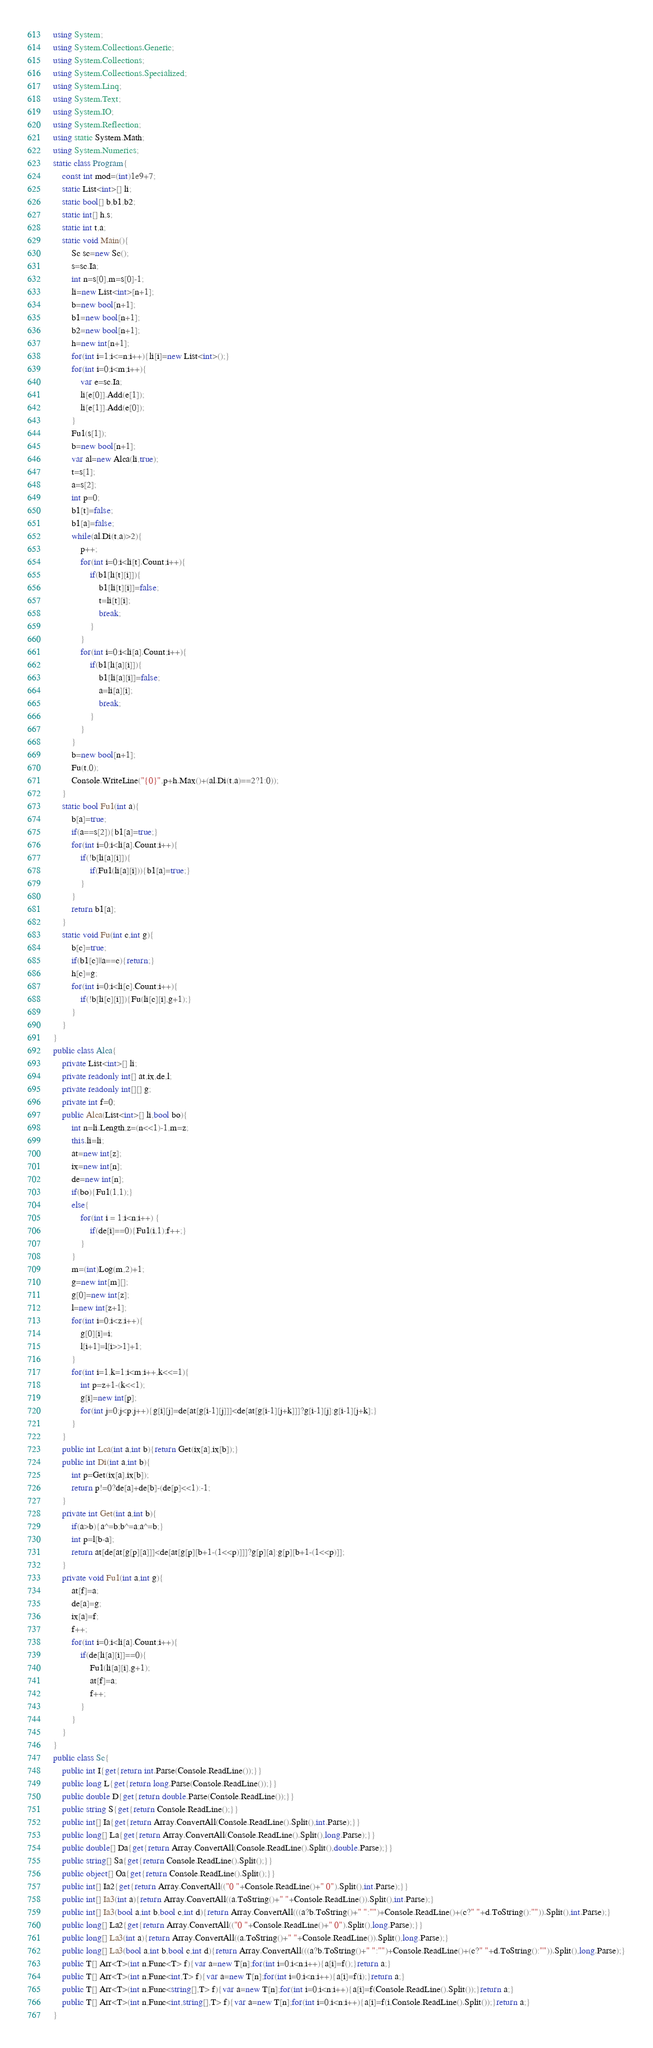Convert code to text. <code><loc_0><loc_0><loc_500><loc_500><_C#_>using System;
using System.Collections.Generic;
using System.Collections;
using System.Collections.Specialized;
using System.Linq;
using System.Text;
using System.IO;
using System.Reflection;
using static System.Math;
using System.Numerics;
static class Program{
	const int mod=(int)1e9+7;
	static List<int>[] li;
	static bool[] b,b1,b2;
	static int[] h,s;
	static int t,a;
	static void Main(){
		Sc sc=new Sc();
		s=sc.Ia;
		int n=s[0],m=s[0]-1;
		li=new List<int>[n+1];
		b=new bool[n+1];
		b1=new bool[n+1];
		b2=new bool[n+1];
		h=new int[n+1];
		for(int i=1;i<=n;i++){li[i]=new List<int>();}
		for(int i=0;i<m;i++){
			var e=sc.Ia;
			li[e[0]].Add(e[1]);
			li[e[1]].Add(e[0]);
		}
		Fu1(s[1]);
		b=new bool[n+1];
		var al=new Alca(li,true);
		t=s[1];
		a=s[2];
		int p=0;
		b1[t]=false;
		b1[a]=false;
		while(al.Di(t,a)>2){
			p++;
			for(int i=0;i<li[t].Count;i++){
				if(b1[li[t][i]]){
					b1[li[t][i]]=false;
					t=li[t][i];
					break;
				}
			}
			for(int i=0;i<li[a].Count;i++){
				if(b1[li[a][i]]){
					b1[li[a][i]]=false;
					a=li[a][i];
					break;
				}
			}
		}
		b=new bool[n+1];
		Fu(t,0);
		Console.WriteLine("{0}",p+h.Max()+(al.Di(t,a)==2?1:0));
	}
	static bool Fu1(int a){
		b[a]=true;
		if(a==s[2]){b1[a]=true;}
		for(int i=0;i<li[a].Count;i++){
			if(!b[li[a][i]]){
				if(Fu1(li[a][i])){b1[a]=true;}
			}
		}
		return b1[a];
	}
	static void Fu(int c,int g){
		b[c]=true;
		if(b1[c]||a==c){return;}
		h[c]=g;
		for(int i=0;i<li[c].Count;i++){
			if(!b[li[c][i]]){Fu(li[c][i],g+1);}
		}
	}
}
public class Alca{
	private List<int>[] li;
	private readonly int[] at,ix,de,l;
	private readonly int[][] g;
	private int f=0;
	public Alca(List<int>[] li,bool bo){
		int n=li.Length,z=(n<<1)-1,m=z;
		this.li=li;
		at=new int[z];
		ix=new int[n];
		de=new int[n];
		if(bo){Fu1(1,1);}
		else{
			for(int i = 1;i<n;i++) {
				if(de[i]==0){Fu1(i,1);f++;}
			}
		}
		m=(int)Log(m,2)+1;
		g=new int[m][];
		g[0]=new int[z];
		l=new int[z+1];
		for(int i=0;i<z;i++){
			g[0][i]=i;
			l[i+1]=l[i>>1]+1;
		}
		for(int i=1,k=1;i<m;i++,k<<=1){
			int p=z+1-(k<<1);
			g[i]=new int[p];
			for(int j=0;j<p;j++){g[i][j]=de[at[g[i-1][j]]]<de[at[g[i-1][j+k]]]?g[i-1][j]:g[i-1][j+k];}
		}
	}
	public int Lca(int a,int b){return Get(ix[a],ix[b]);}
	public int Di(int a,int b){
		int p=Get(ix[a],ix[b]);
		return p!=0?de[a]+de[b]-(de[p]<<1):-1;
	}
	private int Get(int a,int b){
		if(a>b){a^=b;b^=a;a^=b;}
		int p=l[b-a];
		return at[de[at[g[p][a]]]<de[at[g[p][b+1-(1<<p)]]]?g[p][a]:g[p][b+1-(1<<p)]];
	}
	private void Fu1(int a,int g){
		at[f]=a;
		de[a]=g;
		ix[a]=f;
		f++;
		for(int i=0;i<li[a].Count;i++){
			if(de[li[a][i]]==0){
				Fu1(li[a][i],g+1);
				at[f]=a;
				f++;
			}
		}
	}
}
public class Sc{
	public int I{get{return int.Parse(Console.ReadLine());}}
	public long L{get{return long.Parse(Console.ReadLine());}}
	public double D{get{return double.Parse(Console.ReadLine());}}
	public string S{get{return Console.ReadLine();}}
	public int[] Ia{get{return Array.ConvertAll(Console.ReadLine().Split(),int.Parse);}}
	public long[] La{get{return Array.ConvertAll(Console.ReadLine().Split(),long.Parse);}}
	public double[] Da{get{return Array.ConvertAll(Console.ReadLine().Split(),double.Parse);}}
	public string[] Sa{get{return Console.ReadLine().Split();}}
	public object[] Oa{get{return Console.ReadLine().Split();}}
	public int[] Ia2{get{return Array.ConvertAll(("0 "+Console.ReadLine()+" 0").Split(),int.Parse);}}
	public int[] Ia3(int a){return Array.ConvertAll((a.ToString()+" "+Console.ReadLine()).Split(),int.Parse);}
	public int[] Ia3(bool a,int b,bool c,int d){return Array.ConvertAll(((a?b.ToString()+" ":"")+Console.ReadLine()+(c?" "+d.ToString():"")).Split(),int.Parse);}
	public long[] La2{get{return Array.ConvertAll(("0 "+Console.ReadLine()+" 0").Split(),long.Parse);}}
	public long[] La3(int a){return Array.ConvertAll((a.ToString()+" "+Console.ReadLine()).Split(),long.Parse);}
	public long[] La3(bool a,int b,bool c,int d){return Array.ConvertAll(((a?b.ToString()+" ":"")+Console.ReadLine()+(c?" "+d.ToString():"")).Split(),long.Parse);}
	public T[] Arr<T>(int n,Func<T> f){var a=new T[n];for(int i=0;i<n;i++){a[i]=f();}return a;}
	public T[] Arr<T>(int n,Func<int,T> f){var a=new T[n];for(int i=0;i<n;i++){a[i]=f(i);}return a;}
	public T[] Arr<T>(int n,Func<string[],T> f){var a=new T[n];for(int i=0;i<n;i++){a[i]=f(Console.ReadLine().Split());}return a;}
	public T[] Arr<T>(int n,Func<int,string[],T> f){var a=new T[n];for(int i=0;i<n;i++){a[i]=f(i,Console.ReadLine().Split());}return a;}
}</code> 